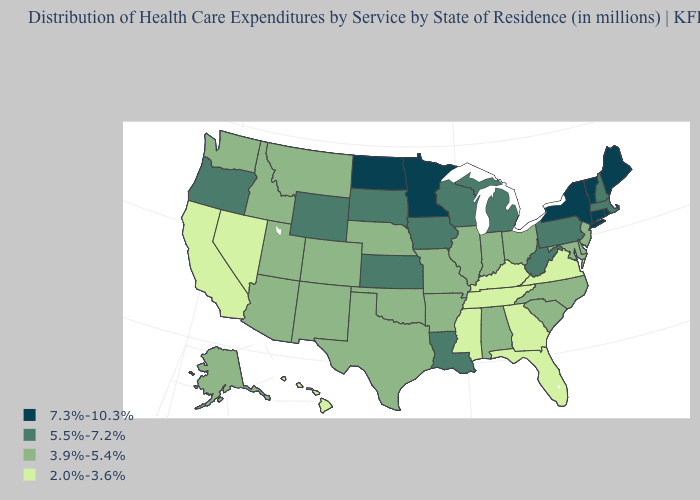Which states have the lowest value in the USA?
Write a very short answer. California, Florida, Georgia, Hawaii, Kentucky, Mississippi, Nevada, Tennessee, Virginia. Name the states that have a value in the range 7.3%-10.3%?
Short answer required. Connecticut, Maine, Minnesota, New York, North Dakota, Rhode Island, Vermont. Is the legend a continuous bar?
Keep it brief. No. Name the states that have a value in the range 2.0%-3.6%?
Keep it brief. California, Florida, Georgia, Hawaii, Kentucky, Mississippi, Nevada, Tennessee, Virginia. Does Alaska have the highest value in the West?
Keep it brief. No. Name the states that have a value in the range 3.9%-5.4%?
Give a very brief answer. Alabama, Alaska, Arizona, Arkansas, Colorado, Delaware, Idaho, Illinois, Indiana, Maryland, Missouri, Montana, Nebraska, New Jersey, New Mexico, North Carolina, Ohio, Oklahoma, South Carolina, Texas, Utah, Washington. Name the states that have a value in the range 7.3%-10.3%?
Be succinct. Connecticut, Maine, Minnesota, New York, North Dakota, Rhode Island, Vermont. What is the lowest value in states that border Idaho?
Keep it brief. 2.0%-3.6%. What is the value of North Dakota?
Keep it brief. 7.3%-10.3%. Name the states that have a value in the range 3.9%-5.4%?
Be succinct. Alabama, Alaska, Arizona, Arkansas, Colorado, Delaware, Idaho, Illinois, Indiana, Maryland, Missouri, Montana, Nebraska, New Jersey, New Mexico, North Carolina, Ohio, Oklahoma, South Carolina, Texas, Utah, Washington. Which states hav the highest value in the MidWest?
Write a very short answer. Minnesota, North Dakota. Does North Carolina have the same value as Missouri?
Be succinct. Yes. Name the states that have a value in the range 2.0%-3.6%?
Be succinct. California, Florida, Georgia, Hawaii, Kentucky, Mississippi, Nevada, Tennessee, Virginia. Name the states that have a value in the range 5.5%-7.2%?
Keep it brief. Iowa, Kansas, Louisiana, Massachusetts, Michigan, New Hampshire, Oregon, Pennsylvania, South Dakota, West Virginia, Wisconsin, Wyoming. Does Maryland have the lowest value in the USA?
Answer briefly. No. 